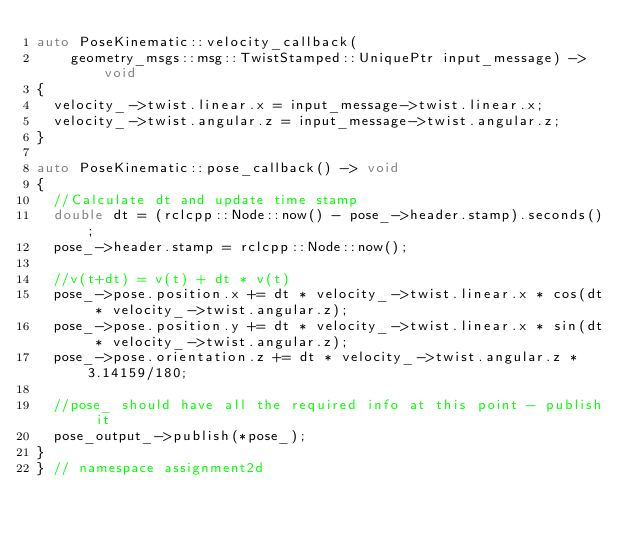<code> <loc_0><loc_0><loc_500><loc_500><_C++_>auto PoseKinematic::velocity_callback(
    geometry_msgs::msg::TwistStamped::UniquePtr input_message) -> void
{
	velocity_->twist.linear.x = input_message->twist.linear.x; 
	velocity_->twist.angular.z = input_message->twist.angular.z; 
}

auto PoseKinematic::pose_callback() -> void
{
	//Calculate dt and update time stamp 
	double dt = (rclcpp::Node::now() - pose_->header.stamp).seconds();
	pose_->header.stamp = rclcpp::Node::now();

	//v(t+dt) = v(t) + dt * v(t)
	pose_->pose.position.x += dt * velocity_->twist.linear.x * cos(dt * velocity_->twist.angular.z); 
	pose_->pose.position.y += dt * velocity_->twist.linear.x * sin(dt * velocity_->twist.angular.z); 
	pose_->pose.orientation.z += dt * velocity_->twist.angular.z * 3.14159/180; 

	//pose_ should have all the required info at this point - publish it
	pose_output_->publish(*pose_);
}
} // namespace assignment2d
</code> 